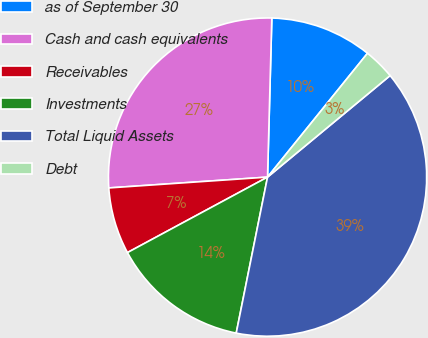Convert chart to OTSL. <chart><loc_0><loc_0><loc_500><loc_500><pie_chart><fcel>as of September 30<fcel>Cash and cash equivalents<fcel>Receivables<fcel>Investments<fcel>Total Liquid Assets<fcel>Debt<nl><fcel>10.38%<fcel>26.51%<fcel>6.78%<fcel>13.98%<fcel>39.16%<fcel>3.18%<nl></chart> 